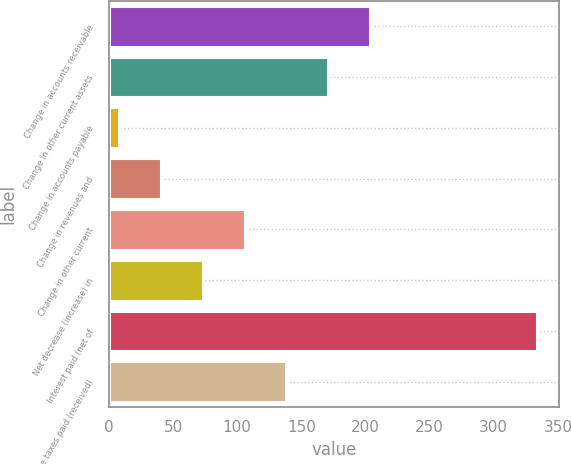<chart> <loc_0><loc_0><loc_500><loc_500><bar_chart><fcel>Change in accounts receivable<fcel>Change in other current assets<fcel>Change in accounts payable<fcel>Change in revenues and<fcel>Change in other current<fcel>Net decrease (increase) in<fcel>Interest paid (net of<fcel>Income taxes paid (received)<nl><fcel>203.6<fcel>171<fcel>8<fcel>40.6<fcel>105.8<fcel>73.2<fcel>334<fcel>138.4<nl></chart> 